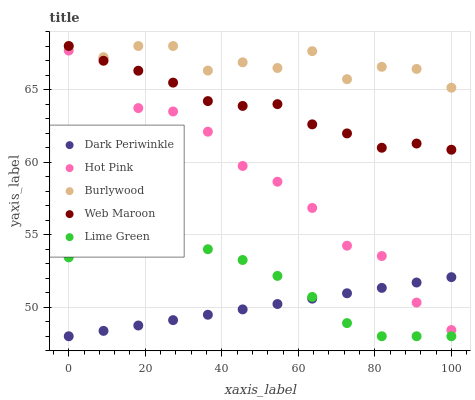Does Dark Periwinkle have the minimum area under the curve?
Answer yes or no. Yes. Does Burlywood have the maximum area under the curve?
Answer yes or no. Yes. Does Lime Green have the minimum area under the curve?
Answer yes or no. No. Does Lime Green have the maximum area under the curve?
Answer yes or no. No. Is Dark Periwinkle the smoothest?
Answer yes or no. Yes. Is Burlywood the roughest?
Answer yes or no. Yes. Is Lime Green the smoothest?
Answer yes or no. No. Is Lime Green the roughest?
Answer yes or no. No. Does Lime Green have the lowest value?
Answer yes or no. Yes. Does Hot Pink have the lowest value?
Answer yes or no. No. Does Web Maroon have the highest value?
Answer yes or no. Yes. Does Lime Green have the highest value?
Answer yes or no. No. Is Dark Periwinkle less than Burlywood?
Answer yes or no. Yes. Is Burlywood greater than Hot Pink?
Answer yes or no. Yes. Does Hot Pink intersect Web Maroon?
Answer yes or no. Yes. Is Hot Pink less than Web Maroon?
Answer yes or no. No. Is Hot Pink greater than Web Maroon?
Answer yes or no. No. Does Dark Periwinkle intersect Burlywood?
Answer yes or no. No. 